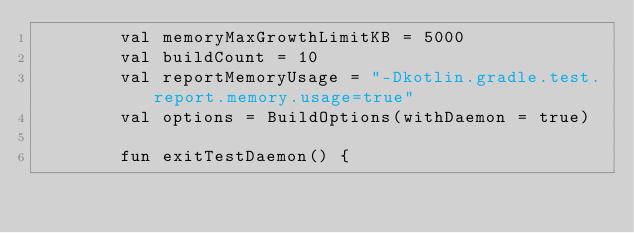<code> <loc_0><loc_0><loc_500><loc_500><_Kotlin_>        val memoryMaxGrowthLimitKB = 5000
        val buildCount = 10
        val reportMemoryUsage = "-Dkotlin.gradle.test.report.memory.usage=true"
        val options = BuildOptions(withDaemon = true)

        fun exitTestDaemon() {</code> 